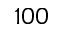Convert formula to latex. <formula><loc_0><loc_0><loc_500><loc_500>1 0 0</formula> 